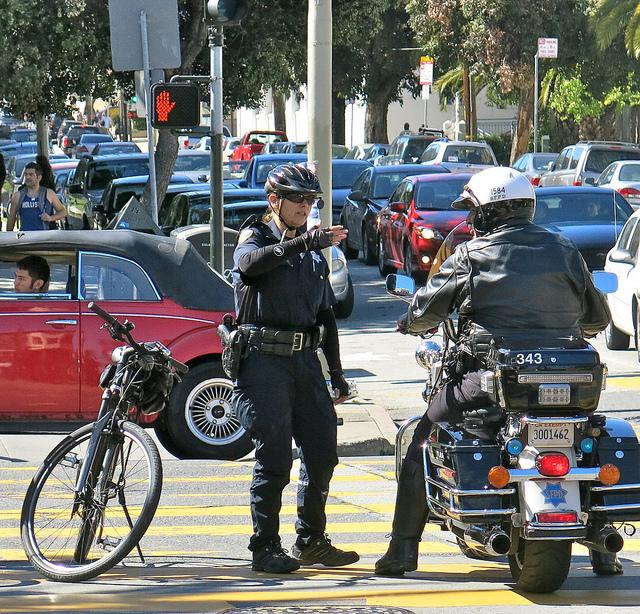What are they discussing?

Choices:
A) traffic
B) gas cost
C) plans date
D) gun cost traffic 